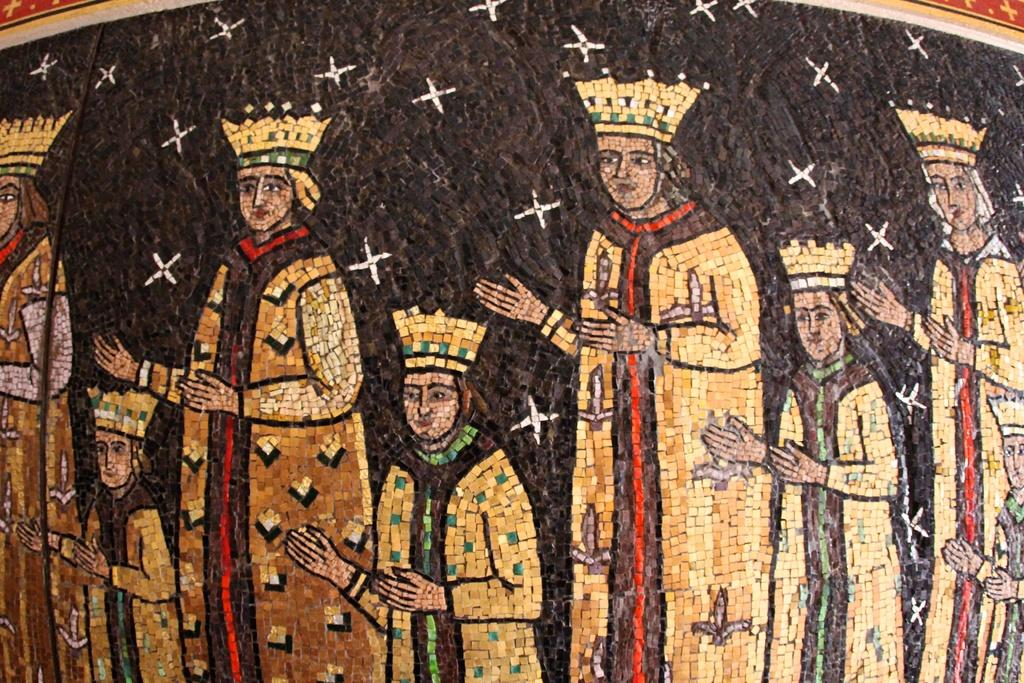What is featured in the center of the image? There are depictions of persons on the wall in the center of the image. Can you describe the subjects of the depictions? The depictions are of persons, but the specific details of the subjects cannot be determined from the provided facts. What type of hand tool is being used by the person in the image? There is no hand tool visible in the image; it only features depictions of persons on the wall. What kind of party is taking place in the image? There is no party depicted in the image; it only features depictions of persons on the wall. 